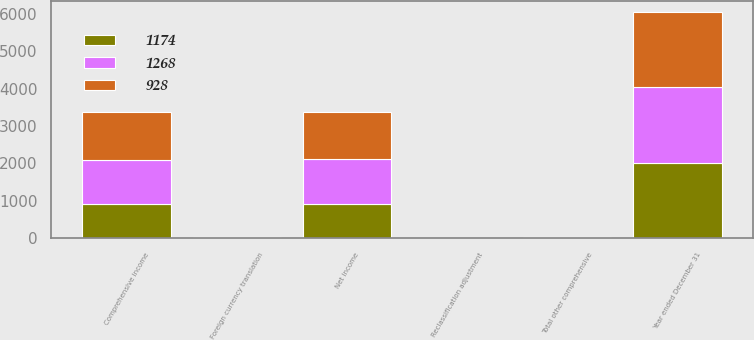Convert chart. <chart><loc_0><loc_0><loc_500><loc_500><stacked_bar_chart><ecel><fcel>Year ended December 31<fcel>Net income<fcel>Reclassification adjustment<fcel>Foreign currency translation<fcel>Total other comprehensive<fcel>Comprehensive income<nl><fcel>1268<fcel>2018<fcel>1187<fcel>4<fcel>11<fcel>13<fcel>1174<nl><fcel>928<fcel>2017<fcel>1246<fcel>6<fcel>12<fcel>22<fcel>1268<nl><fcel>1174<fcel>2016<fcel>930<fcel>7<fcel>9<fcel>2<fcel>928<nl></chart> 